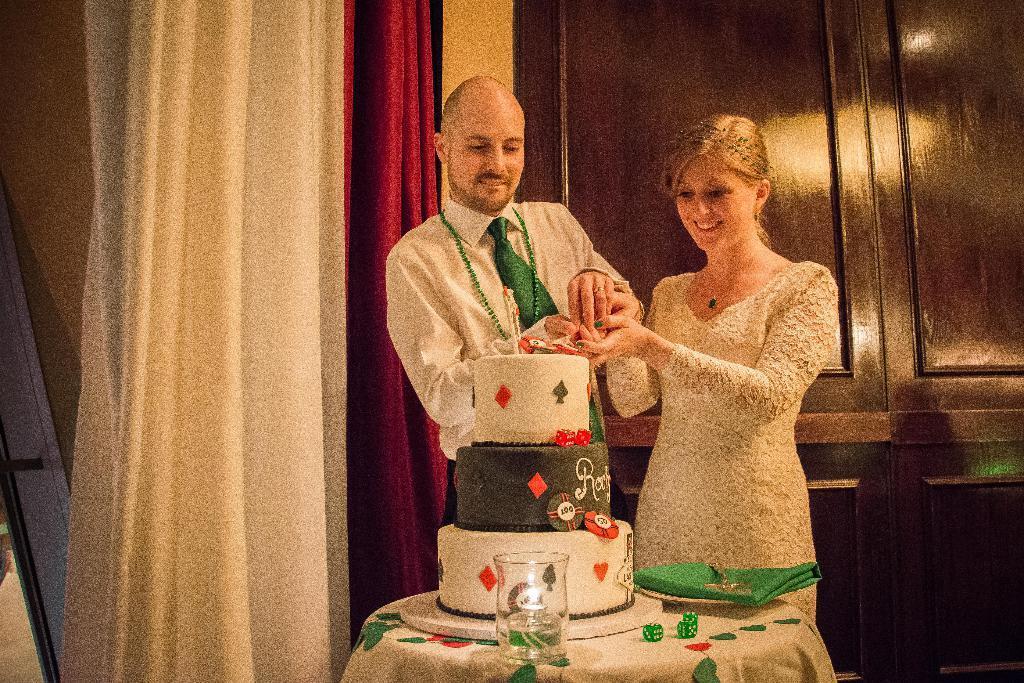Can you describe this image briefly? There is one man and a woman standing and holding an object as we can see in the middle of this image. There is a cake, glass and other objects are present on the surface which is at the bottom of this image. We can see a wall and curtains in the background. 